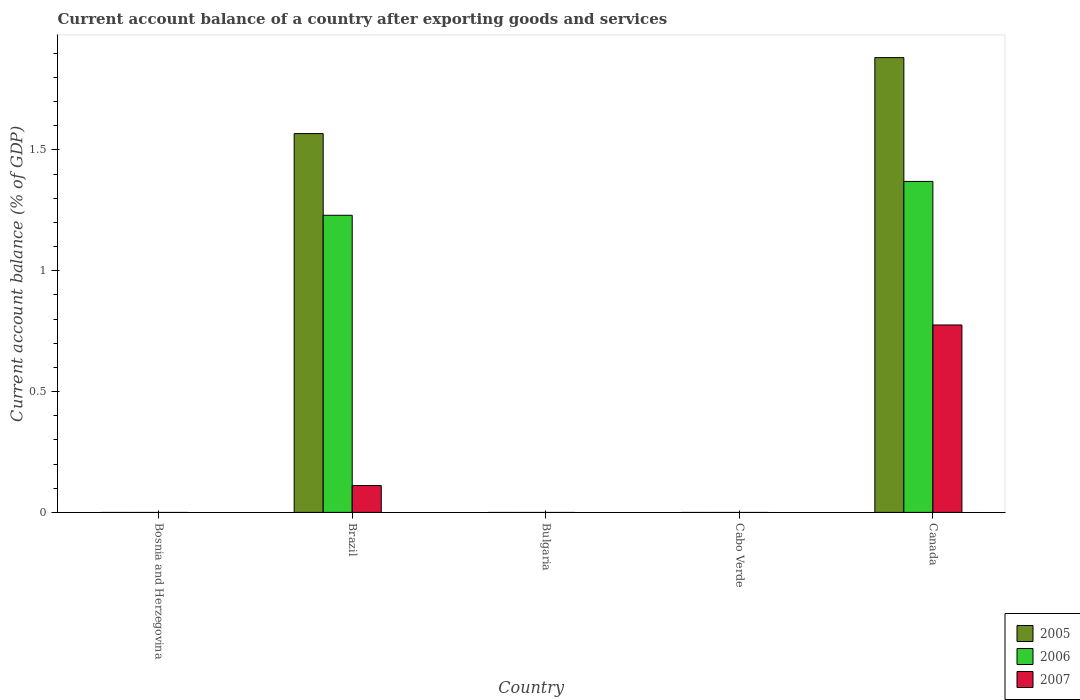How many different coloured bars are there?
Give a very brief answer. 3. Are the number of bars per tick equal to the number of legend labels?
Make the answer very short. No. Are the number of bars on each tick of the X-axis equal?
Your response must be concise. No. How many bars are there on the 3rd tick from the left?
Give a very brief answer. 0. What is the label of the 1st group of bars from the left?
Ensure brevity in your answer.  Bosnia and Herzegovina. Across all countries, what is the maximum account balance in 2006?
Offer a very short reply. 1.37. Across all countries, what is the minimum account balance in 2006?
Offer a terse response. 0. In which country was the account balance in 2007 maximum?
Offer a very short reply. Canada. What is the total account balance in 2005 in the graph?
Provide a succinct answer. 3.45. What is the difference between the account balance in 2007 in Brazil and that in Canada?
Offer a very short reply. -0.66. What is the difference between the account balance in 2007 in Cabo Verde and the account balance in 2005 in Brazil?
Your answer should be compact. -1.57. What is the average account balance in 2006 per country?
Offer a terse response. 0.52. What is the difference between the account balance of/in 2005 and account balance of/in 2007 in Brazil?
Make the answer very short. 1.46. In how many countries, is the account balance in 2007 greater than 0.1 %?
Provide a succinct answer. 2. What is the difference between the highest and the lowest account balance in 2006?
Provide a succinct answer. 1.37. Are all the bars in the graph horizontal?
Provide a succinct answer. No. How are the legend labels stacked?
Give a very brief answer. Vertical. What is the title of the graph?
Your response must be concise. Current account balance of a country after exporting goods and services. What is the label or title of the X-axis?
Offer a very short reply. Country. What is the label or title of the Y-axis?
Give a very brief answer. Current account balance (% of GDP). What is the Current account balance (% of GDP) in 2006 in Bosnia and Herzegovina?
Provide a short and direct response. 0. What is the Current account balance (% of GDP) in 2007 in Bosnia and Herzegovina?
Offer a very short reply. 0. What is the Current account balance (% of GDP) of 2005 in Brazil?
Your response must be concise. 1.57. What is the Current account balance (% of GDP) in 2006 in Brazil?
Your answer should be very brief. 1.23. What is the Current account balance (% of GDP) of 2007 in Brazil?
Provide a succinct answer. 0.11. What is the Current account balance (% of GDP) in 2005 in Canada?
Keep it short and to the point. 1.88. What is the Current account balance (% of GDP) of 2006 in Canada?
Give a very brief answer. 1.37. What is the Current account balance (% of GDP) of 2007 in Canada?
Your response must be concise. 0.78. Across all countries, what is the maximum Current account balance (% of GDP) of 2005?
Make the answer very short. 1.88. Across all countries, what is the maximum Current account balance (% of GDP) of 2006?
Provide a succinct answer. 1.37. Across all countries, what is the maximum Current account balance (% of GDP) in 2007?
Ensure brevity in your answer.  0.78. Across all countries, what is the minimum Current account balance (% of GDP) of 2005?
Make the answer very short. 0. Across all countries, what is the minimum Current account balance (% of GDP) of 2007?
Provide a short and direct response. 0. What is the total Current account balance (% of GDP) of 2005 in the graph?
Make the answer very short. 3.45. What is the total Current account balance (% of GDP) of 2006 in the graph?
Keep it short and to the point. 2.6. What is the total Current account balance (% of GDP) of 2007 in the graph?
Offer a terse response. 0.89. What is the difference between the Current account balance (% of GDP) of 2005 in Brazil and that in Canada?
Your answer should be very brief. -0.31. What is the difference between the Current account balance (% of GDP) in 2006 in Brazil and that in Canada?
Offer a very short reply. -0.14. What is the difference between the Current account balance (% of GDP) in 2007 in Brazil and that in Canada?
Keep it short and to the point. -0.66. What is the difference between the Current account balance (% of GDP) of 2005 in Brazil and the Current account balance (% of GDP) of 2006 in Canada?
Offer a very short reply. 0.2. What is the difference between the Current account balance (% of GDP) in 2005 in Brazil and the Current account balance (% of GDP) in 2007 in Canada?
Your answer should be compact. 0.79. What is the difference between the Current account balance (% of GDP) in 2006 in Brazil and the Current account balance (% of GDP) in 2007 in Canada?
Your response must be concise. 0.45. What is the average Current account balance (% of GDP) in 2005 per country?
Offer a terse response. 0.69. What is the average Current account balance (% of GDP) in 2006 per country?
Your response must be concise. 0.52. What is the average Current account balance (% of GDP) of 2007 per country?
Keep it short and to the point. 0.18. What is the difference between the Current account balance (% of GDP) in 2005 and Current account balance (% of GDP) in 2006 in Brazil?
Provide a short and direct response. 0.34. What is the difference between the Current account balance (% of GDP) of 2005 and Current account balance (% of GDP) of 2007 in Brazil?
Offer a terse response. 1.46. What is the difference between the Current account balance (% of GDP) in 2006 and Current account balance (% of GDP) in 2007 in Brazil?
Keep it short and to the point. 1.12. What is the difference between the Current account balance (% of GDP) in 2005 and Current account balance (% of GDP) in 2006 in Canada?
Your answer should be very brief. 0.51. What is the difference between the Current account balance (% of GDP) of 2005 and Current account balance (% of GDP) of 2007 in Canada?
Give a very brief answer. 1.11. What is the difference between the Current account balance (% of GDP) of 2006 and Current account balance (% of GDP) of 2007 in Canada?
Offer a very short reply. 0.59. What is the ratio of the Current account balance (% of GDP) of 2005 in Brazil to that in Canada?
Provide a succinct answer. 0.83. What is the ratio of the Current account balance (% of GDP) in 2006 in Brazil to that in Canada?
Provide a succinct answer. 0.9. What is the ratio of the Current account balance (% of GDP) in 2007 in Brazil to that in Canada?
Keep it short and to the point. 0.14. What is the difference between the highest and the lowest Current account balance (% of GDP) of 2005?
Offer a very short reply. 1.88. What is the difference between the highest and the lowest Current account balance (% of GDP) in 2006?
Give a very brief answer. 1.37. What is the difference between the highest and the lowest Current account balance (% of GDP) in 2007?
Provide a succinct answer. 0.78. 